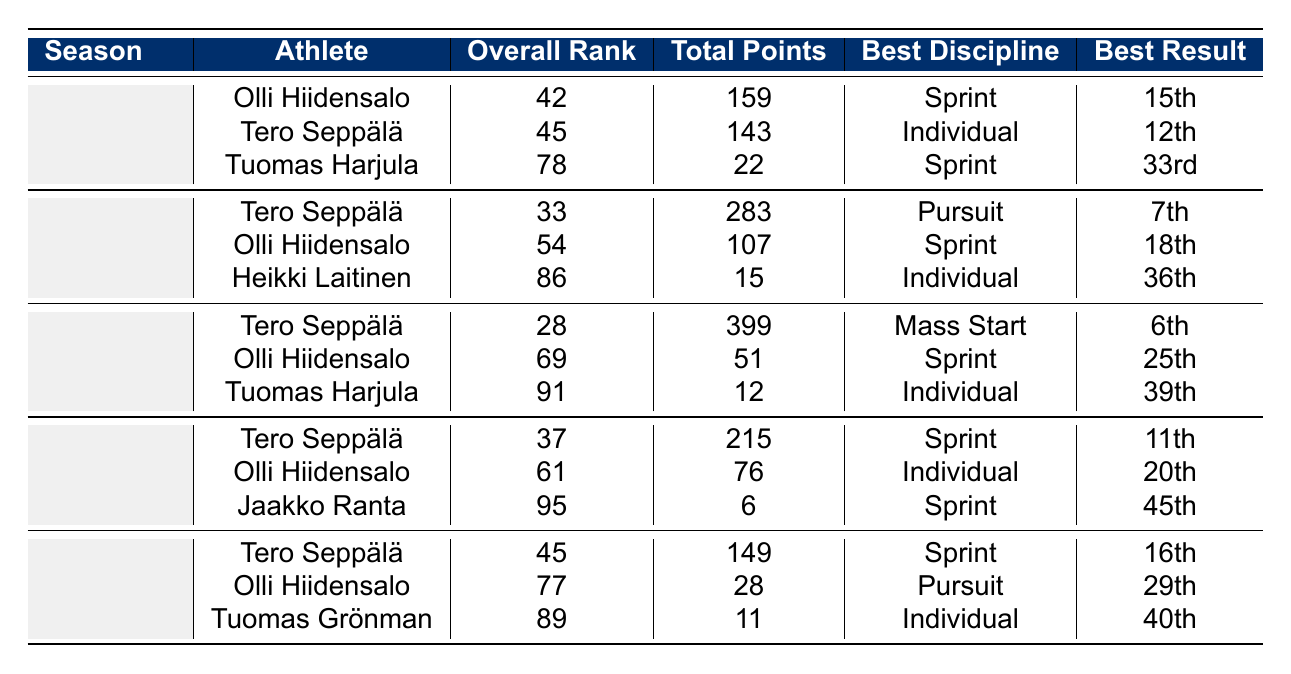What was Tero Seppälä's best result in the 2021-2022 season? In the 2021-2022 season, Tero Seppälä's best result listed in the table is 7th place in Pursuit.
Answer: 7th Which athlete had the highest total points in the 2020-2021 season? In the 2020-2021 season, Tero Seppälä scored 399 points, which is higher than any other athlete's total in that season.
Answer: Tero Seppälä What was Olli Hiidensalo's overall rank in the 2019-2020 season? Olli Hiidensalo ranked 61st overall in the 2019-2020 season according to the table.
Answer: 61 Which two seasons did Olli Hiidensalo have his best results in? Olli Hiidensalo had his best results in the 2022-2023 season (15th) and the 2020-2021 season (25th), which are the highest placements listed for him in the table.
Answer: 2022-2023 and 2020-2021 What is the average total points scored by Tero Seppälä across all seasons? The total points scored by Tero Seppälä are 149 (2018-2019) + 215 (2019-2020) + 399 (2020-2021) + 283 (2021-2022) + 143 (2022-2023) = 1189; dividing this by 5 seasons gives an average of 237.8.
Answer: 237.8 Did Tuomas Harjula achieve a better ranking than Olli Hiidensalo in the 2022-2023 season? In the 2022-2023 season, Tuomas Harjula ranked 78th while Olli Hiidensalo ranked 42nd, making Harjula's ranking worse.
Answer: No How many points did Olli Hiidensalo score in the 2020-2021 season compared to 2021-2022? Olli Hiidensalo scored 51 points in the 2020-2021 season and 107 points in the 2021-2022 season. The difference is 107 - 51 = 56 points.
Answer: 56 points Which athlete had the least amount of total points in the 2019-2020 season? In the 2019-2020 season, Jaakko Ranta had the least total points with 6, as indicated in the table.
Answer: Jaakko Ranta How many Finnish athletes participated in the 2018-2019 season? The table shows there were three athletes listed for the 2018-2019 season: Tero Seppälä, Olli Hiidensalo, and Tuomas Grönman.
Answer: 3 What is the best discipline for Tuomas Harjula in the 2020-2021 season? Tuomas Harjula's best discipline listed for the 2020-2021 season is Individual.
Answer: Individual Which season had the athlete with the lowest overall rank, and what was the rank? The 2020-2021 season includes Tuomas Harjula with an overall rank of 91, which is the lowest among all listed ranks.
Answer: 91 in the 2020-2021 season 